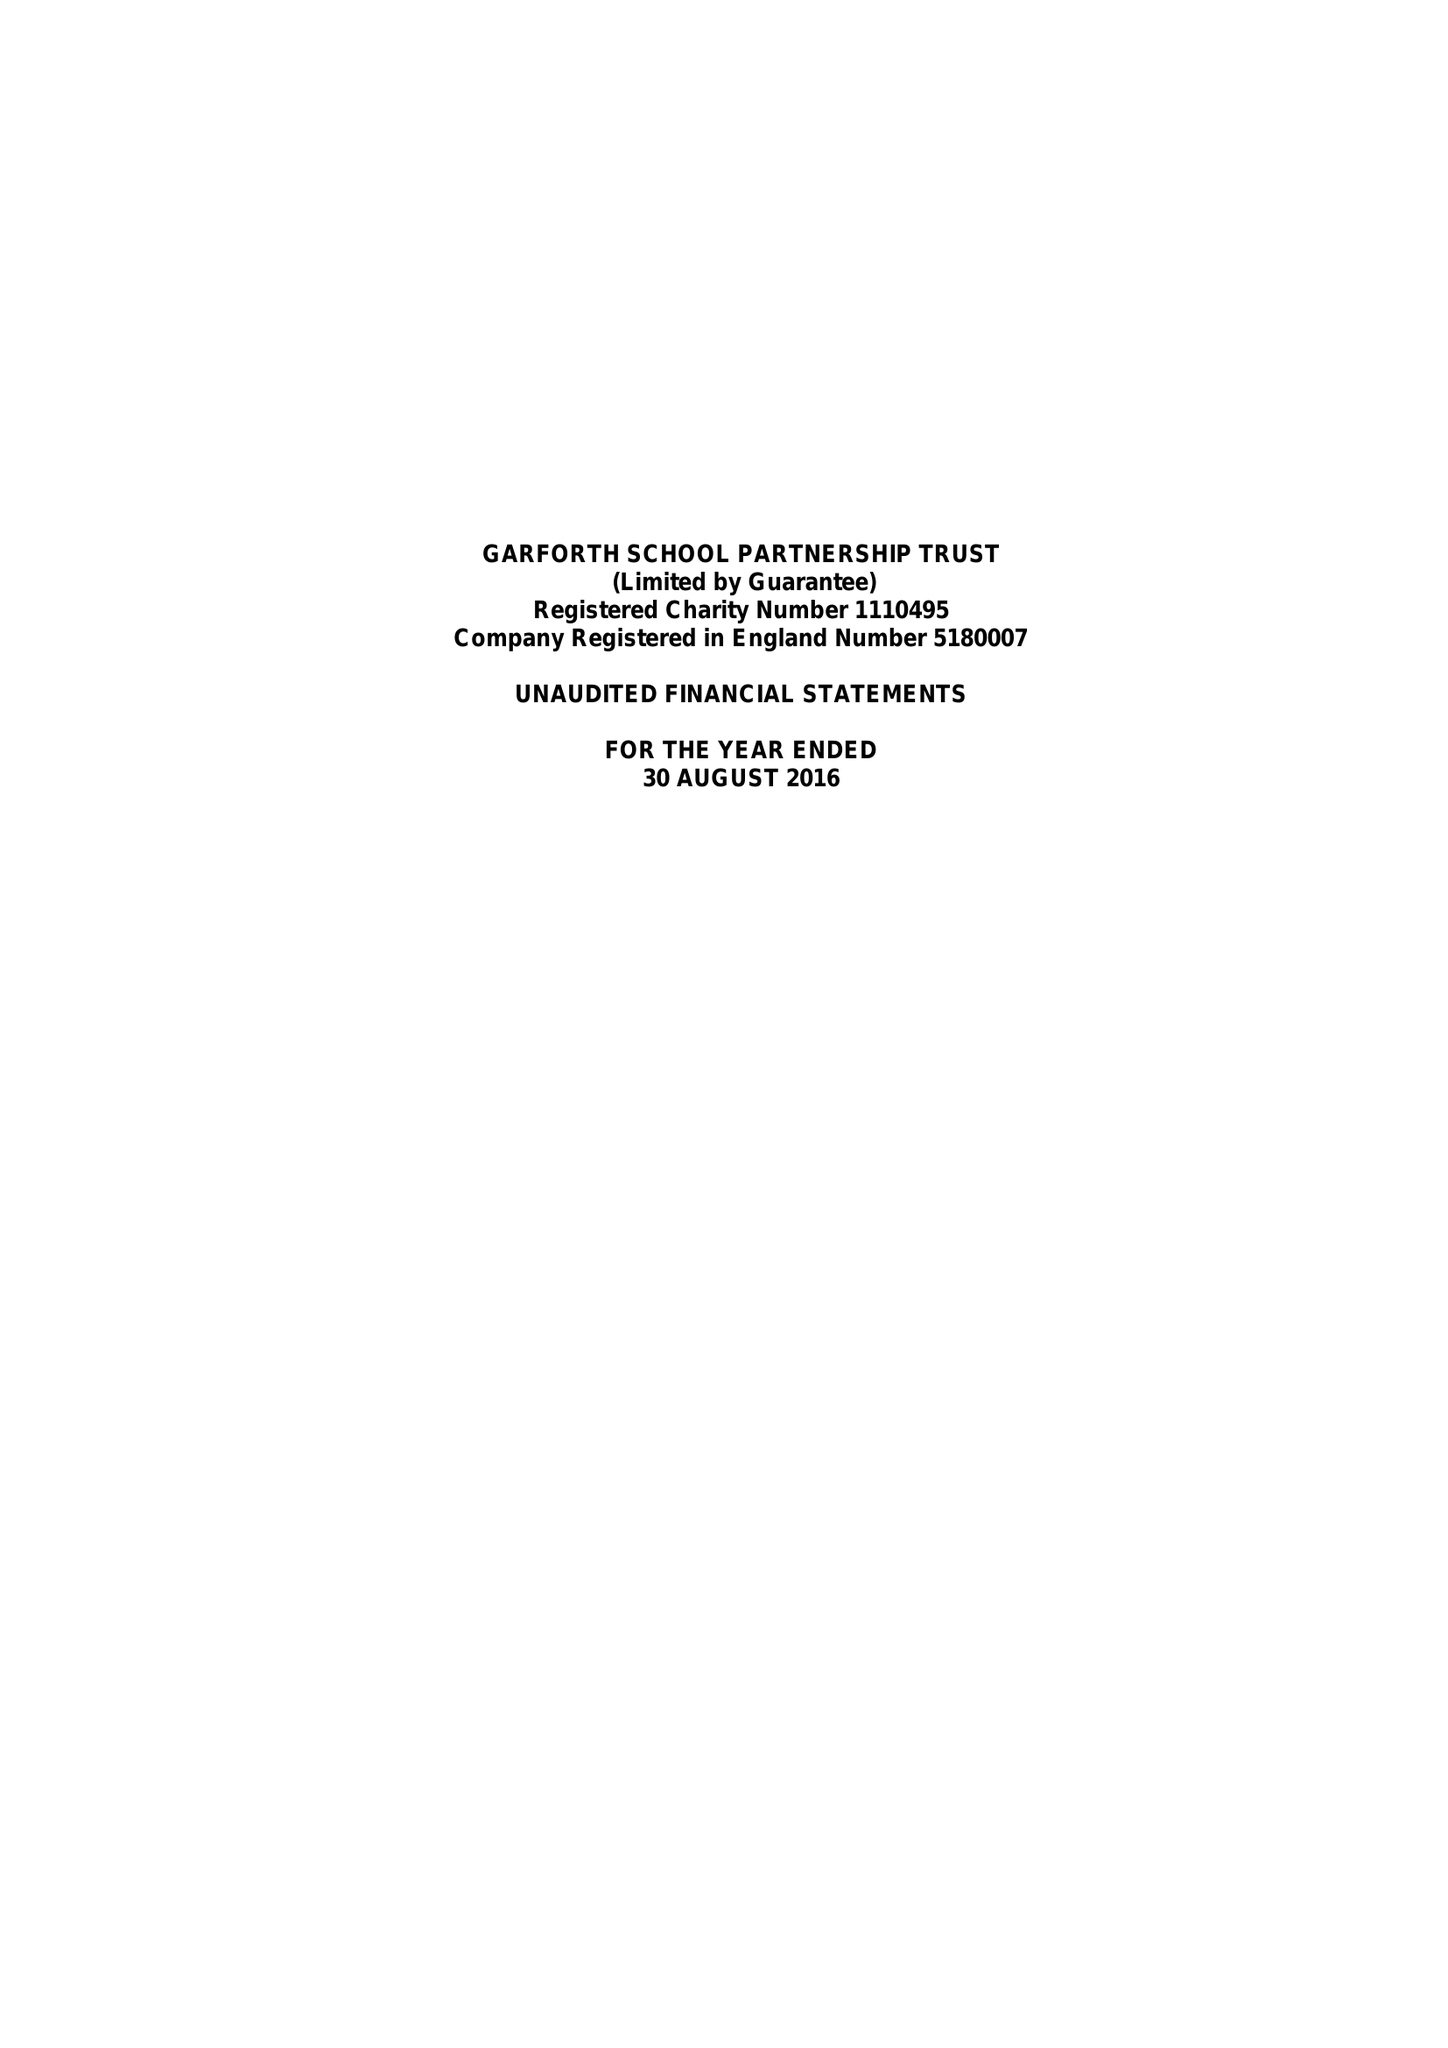What is the value for the report_date?
Answer the question using a single word or phrase. 2016-08-30 